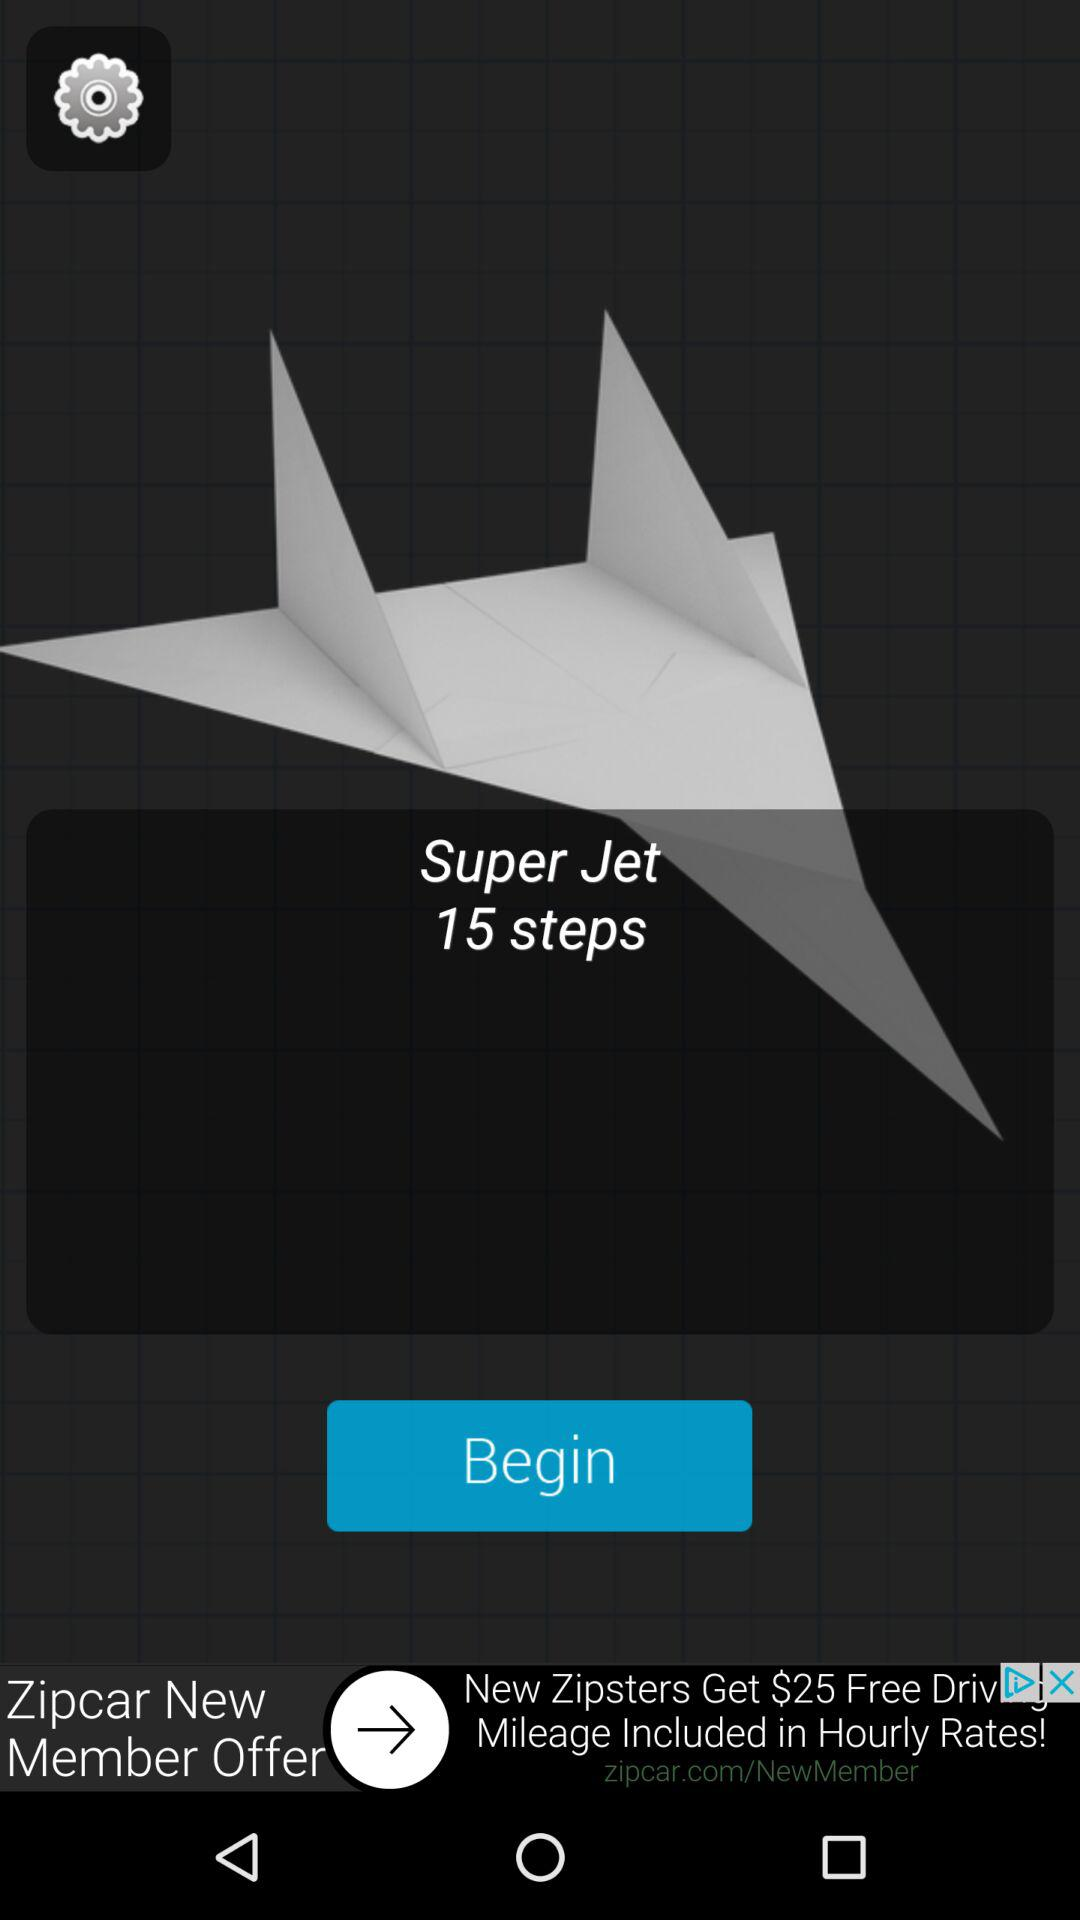How many steps are there in the "Super Jet"? There are 15 steps in the "Super Jet". 